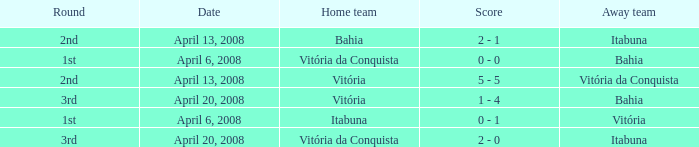What is the name of the home team on April 13, 2008 when Itabuna was the away team? Bahia. 